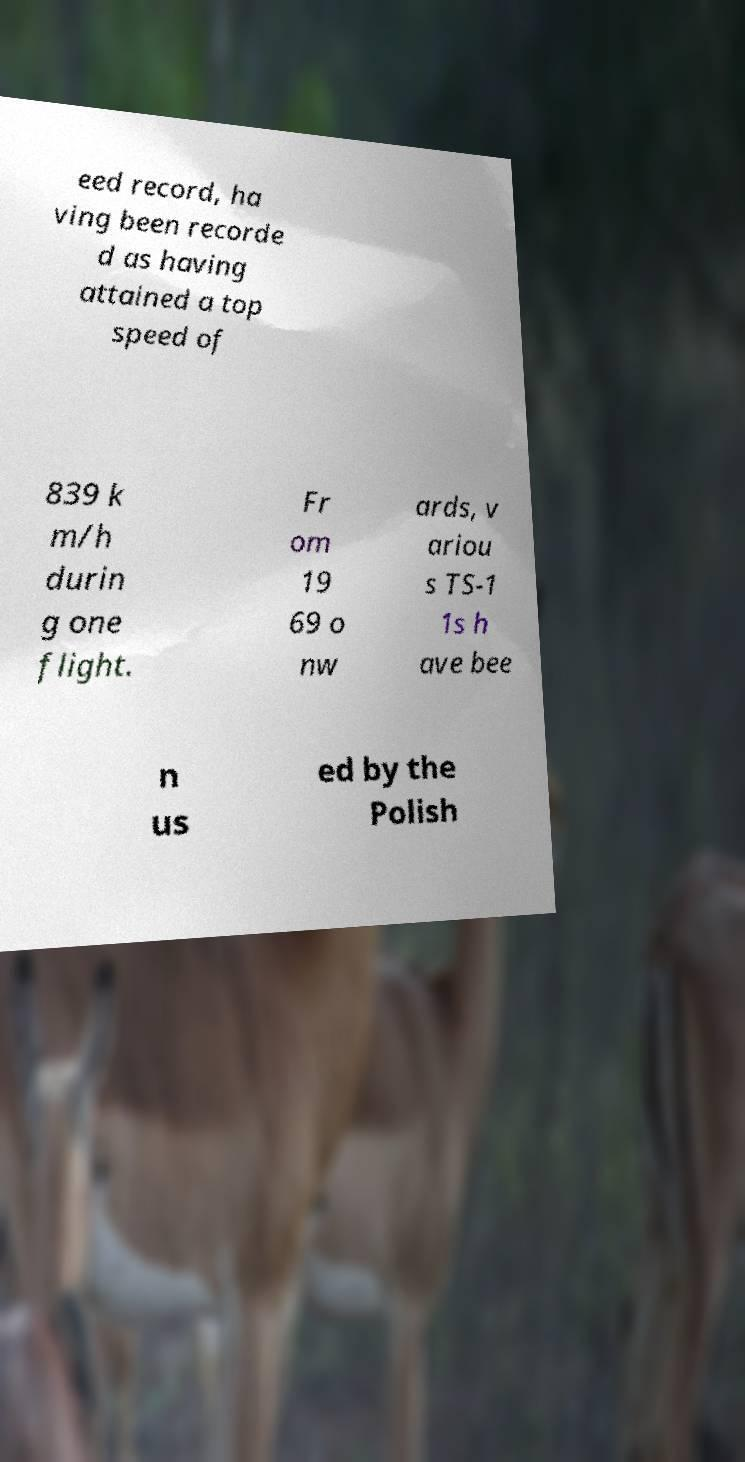Could you extract and type out the text from this image? eed record, ha ving been recorde d as having attained a top speed of 839 k m/h durin g one flight. Fr om 19 69 o nw ards, v ariou s TS-1 1s h ave bee n us ed by the Polish 